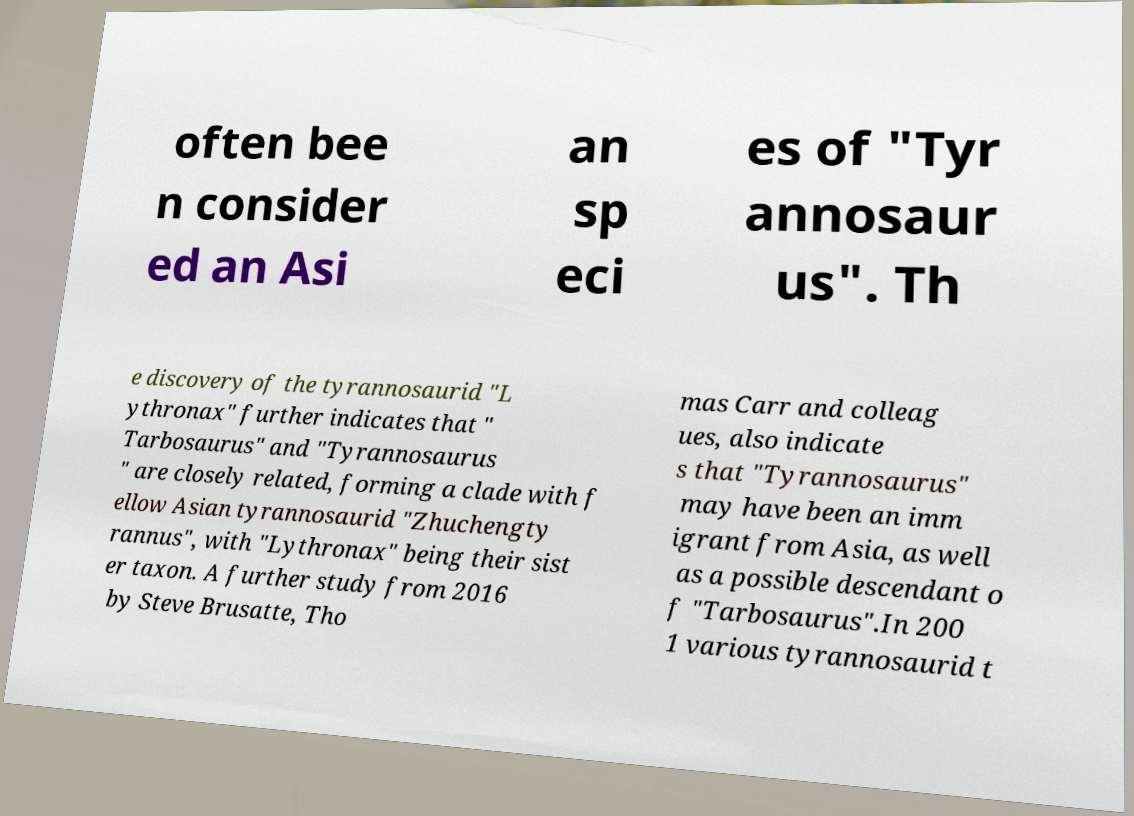Please identify and transcribe the text found in this image. often bee n consider ed an Asi an sp eci es of "Tyr annosaur us". Th e discovery of the tyrannosaurid "L ythronax" further indicates that " Tarbosaurus" and "Tyrannosaurus " are closely related, forming a clade with f ellow Asian tyrannosaurid "Zhuchengty rannus", with "Lythronax" being their sist er taxon. A further study from 2016 by Steve Brusatte, Tho mas Carr and colleag ues, also indicate s that "Tyrannosaurus" may have been an imm igrant from Asia, as well as a possible descendant o f "Tarbosaurus".In 200 1 various tyrannosaurid t 